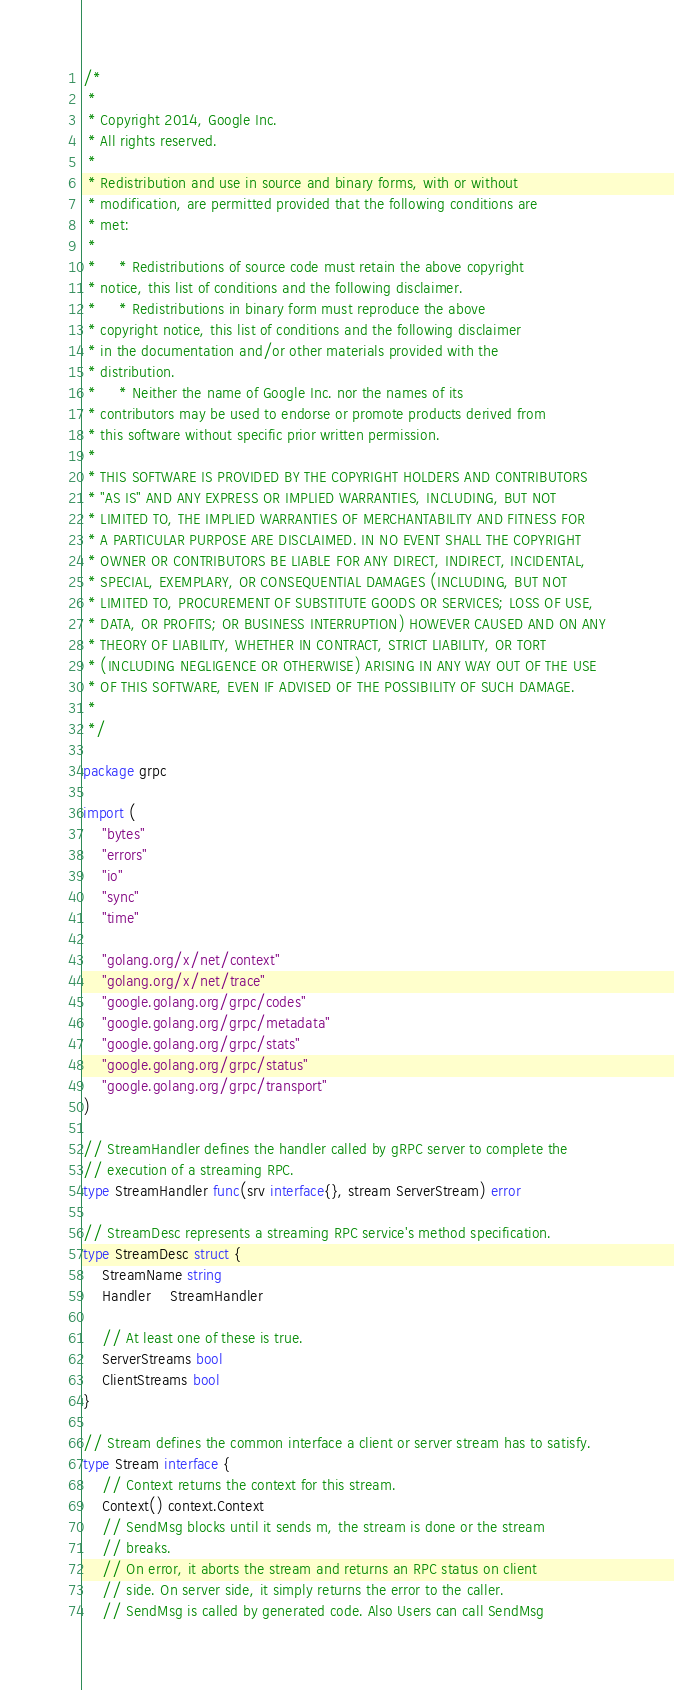<code> <loc_0><loc_0><loc_500><loc_500><_Go_>/*
 *
 * Copyright 2014, Google Inc.
 * All rights reserved.
 *
 * Redistribution and use in source and binary forms, with or without
 * modification, are permitted provided that the following conditions are
 * met:
 *
 *     * Redistributions of source code must retain the above copyright
 * notice, this list of conditions and the following disclaimer.
 *     * Redistributions in binary form must reproduce the above
 * copyright notice, this list of conditions and the following disclaimer
 * in the documentation and/or other materials provided with the
 * distribution.
 *     * Neither the name of Google Inc. nor the names of its
 * contributors may be used to endorse or promote products derived from
 * this software without specific prior written permission.
 *
 * THIS SOFTWARE IS PROVIDED BY THE COPYRIGHT HOLDERS AND CONTRIBUTORS
 * "AS IS" AND ANY EXPRESS OR IMPLIED WARRANTIES, INCLUDING, BUT NOT
 * LIMITED TO, THE IMPLIED WARRANTIES OF MERCHANTABILITY AND FITNESS FOR
 * A PARTICULAR PURPOSE ARE DISCLAIMED. IN NO EVENT SHALL THE COPYRIGHT
 * OWNER OR CONTRIBUTORS BE LIABLE FOR ANY DIRECT, INDIRECT, INCIDENTAL,
 * SPECIAL, EXEMPLARY, OR CONSEQUENTIAL DAMAGES (INCLUDING, BUT NOT
 * LIMITED TO, PROCUREMENT OF SUBSTITUTE GOODS OR SERVICES; LOSS OF USE,
 * DATA, OR PROFITS; OR BUSINESS INTERRUPTION) HOWEVER CAUSED AND ON ANY
 * THEORY OF LIABILITY, WHETHER IN CONTRACT, STRICT LIABILITY, OR TORT
 * (INCLUDING NEGLIGENCE OR OTHERWISE) ARISING IN ANY WAY OUT OF THE USE
 * OF THIS SOFTWARE, EVEN IF ADVISED OF THE POSSIBILITY OF SUCH DAMAGE.
 *
 */

package grpc

import (
	"bytes"
	"errors"
	"io"
	"sync"
	"time"

	"golang.org/x/net/context"
	"golang.org/x/net/trace"
	"google.golang.org/grpc/codes"
	"google.golang.org/grpc/metadata"
	"google.golang.org/grpc/stats"
	"google.golang.org/grpc/status"
	"google.golang.org/grpc/transport"
)

// StreamHandler defines the handler called by gRPC server to complete the
// execution of a streaming RPC.
type StreamHandler func(srv interface{}, stream ServerStream) error

// StreamDesc represents a streaming RPC service's method specification.
type StreamDesc struct {
	StreamName string
	Handler    StreamHandler

	// At least one of these is true.
	ServerStreams bool
	ClientStreams bool
}

// Stream defines the common interface a client or server stream has to satisfy.
type Stream interface {
	// Context returns the context for this stream.
	Context() context.Context
	// SendMsg blocks until it sends m, the stream is done or the stream
	// breaks.
	// On error, it aborts the stream and returns an RPC status on client
	// side. On server side, it simply returns the error to the caller.
	// SendMsg is called by generated code. Also Users can call SendMsg</code> 